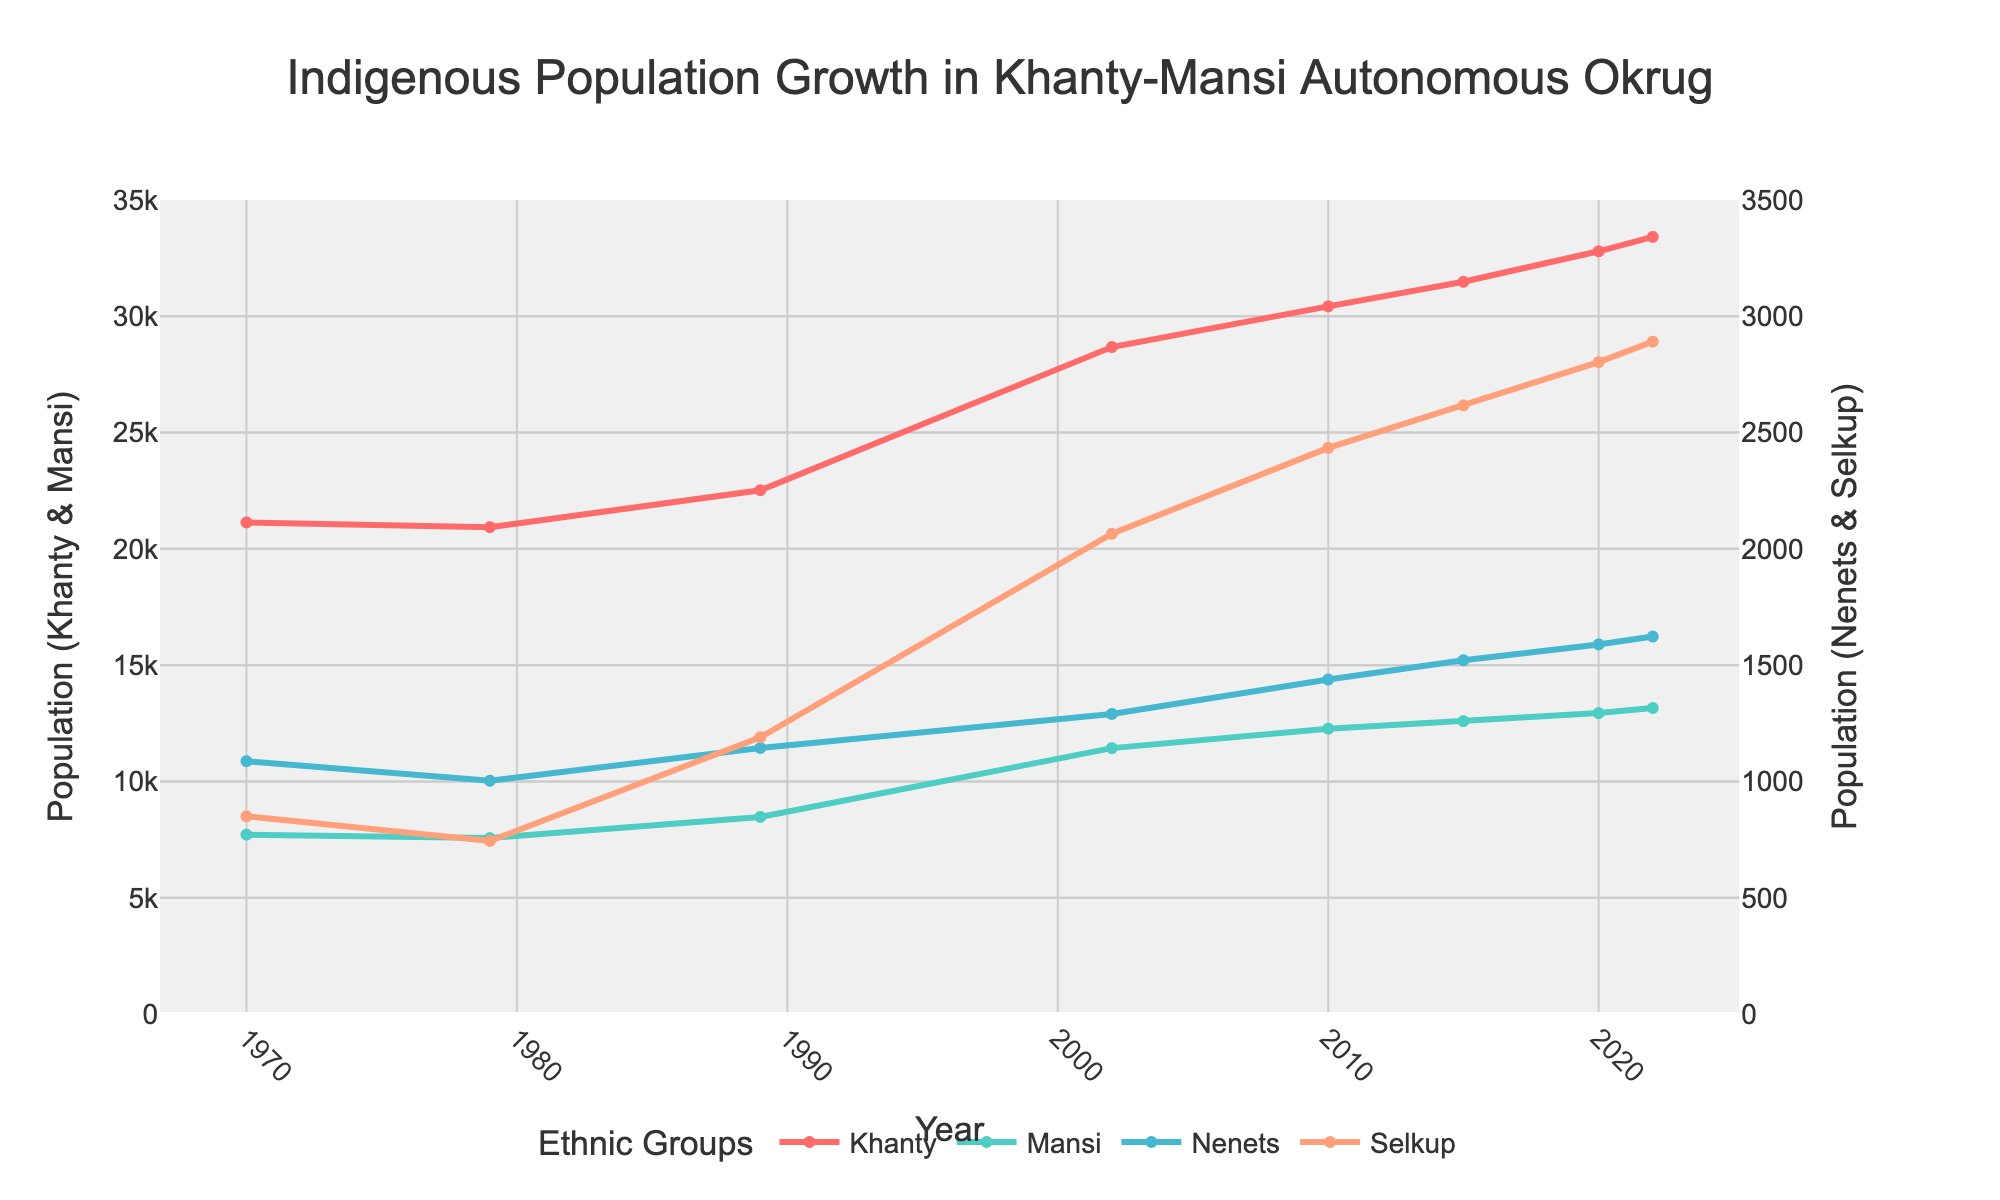What is the total population of the Khanty and Mansi ethnic groups in 2022? To find the total population of the Khanty and Mansi ethnic groups in 2022, sum the populations of both groups for that year. From the figure, Khanty has 33,412 people and Mansi has 13,157 people in 2022. Therefore, the total population is 33,412 + 13,157 = 46,569.
Answer: 46,569 Which ethnic group experienced the largest increase in population between 1970 and 2022? To determine the ethnic group with the largest increase, subtract the 1970 population from the 2022 population for all groups. The increases are Khanty: 33,412 - 21,138 = 12,274, Mansi: 13,157 - 7,710 = 5,447, Nenets: 1,623 - 1,087 = 536, Selkup: 2,891 - 850 = 2,041. The Khanty group experienced the largest increase.
Answer: Khanty In which year did the Mansi population exceed 10,000? To find the first year when the Mansi population exceeded 10,000, look for the first data point where the Mansi curve crosses the 10,000 mark. According to the figure, this occurs between 1989 and 2002. Specifically, the data shows Mansi reached 11,432 in 2002.
Answer: 2002 How does the population growth pattern of the Nenets compare to that of the Selkup from 1970 to 2022? To compare the population growth patterns, observe the trends in the lines for Nenets and Selkup over the years. Nenets had a relatively steady increase from 1,087 in 1970 to 1,623 in 2022, whereas Selkup showed a more pronounced increase, especially after 1989, going from 850 in 1970 to 2,891 in 2022. Selkup had a sharper increase overall compared to Nenets.
Answer: Selkup grew more sharply What is the average annual population increase of the Khanty between 1970 and 2022? First, find the total increase in the Khanty population from 1970 to 2022, which is 33,412 - 21,138 = 12,274. Next, calculate the number of years between 1970 and 2022: 2022 - 1970 = 52 years. The average annual increase is then 12,274 / 52 ≈ 235.
Answer: 235 What visual attribute differentiates the Khanty and Mansi lines in the plot? Observe the color and style of the lines. The Khanty line is represented in red, while the Mansi line is in greenish-blue. Additionally, the lines for both ethnic groups are shown with markers and are solid, but differ in their color representation.
Answer: Color How did the trend in the Selkup population change after 1989? To understand the trend change, look for the slope of the Selkup line before and after 1989. Before 1989, the population grew slowly, but after 1989, there is a noticeable steeper upward trend indicating a faster increase in the population.
Answer: Steeper increase after 1989 